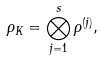<formula> <loc_0><loc_0><loc_500><loc_500>\rho _ { K } = \bigotimes _ { j = 1 } ^ { s } \rho ^ { ( j ) } ,</formula> 